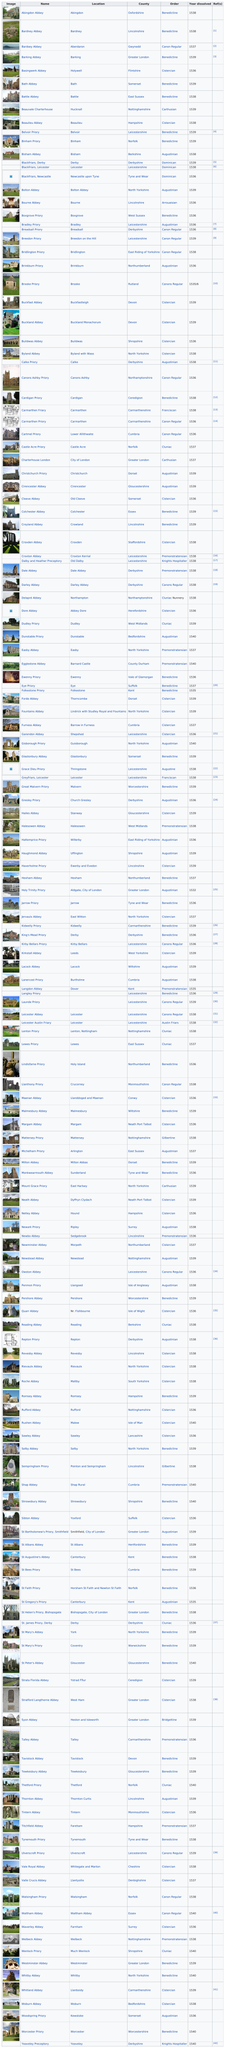Point out several critical features in this image. There is only one abbey listed for the location of Holywell. Basingwerk Abbey is a Cistercian order abbey. The difference in the year dissolved between Abingdon Abbey and Bardsey Abbey is unknown. The order of Bardney Abbey is the same as Abingdon Abbey. In 1539, Bath Abbey was dissolved by Henry VIII. 